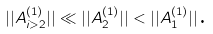Convert formula to latex. <formula><loc_0><loc_0><loc_500><loc_500>| | A _ { i > 2 } ^ { ( 1 ) } | | \ll | | A _ { 2 } ^ { ( 1 ) } | | < | | A _ { 1 } ^ { ( 1 ) } | | \text {.}</formula> 